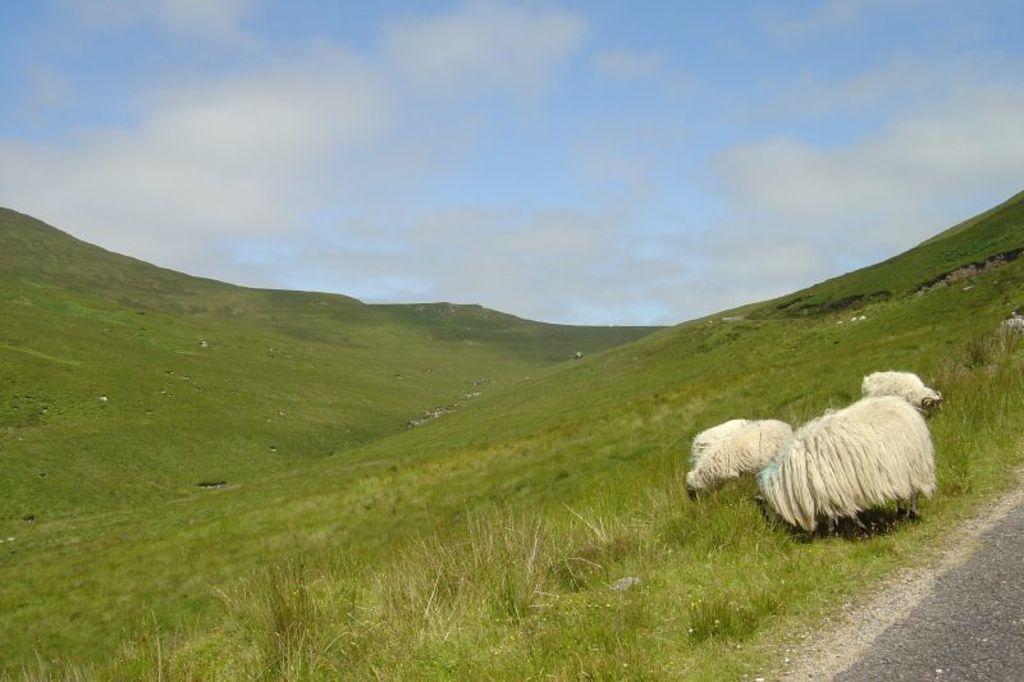Please provide a concise description of this image. In the picture we can see a slope with grass surface on it, we can see four sheep are standing and grazing the grass and far away from it, we can see a hill slope with grass surface and behind it we can see a sky with clouds. 